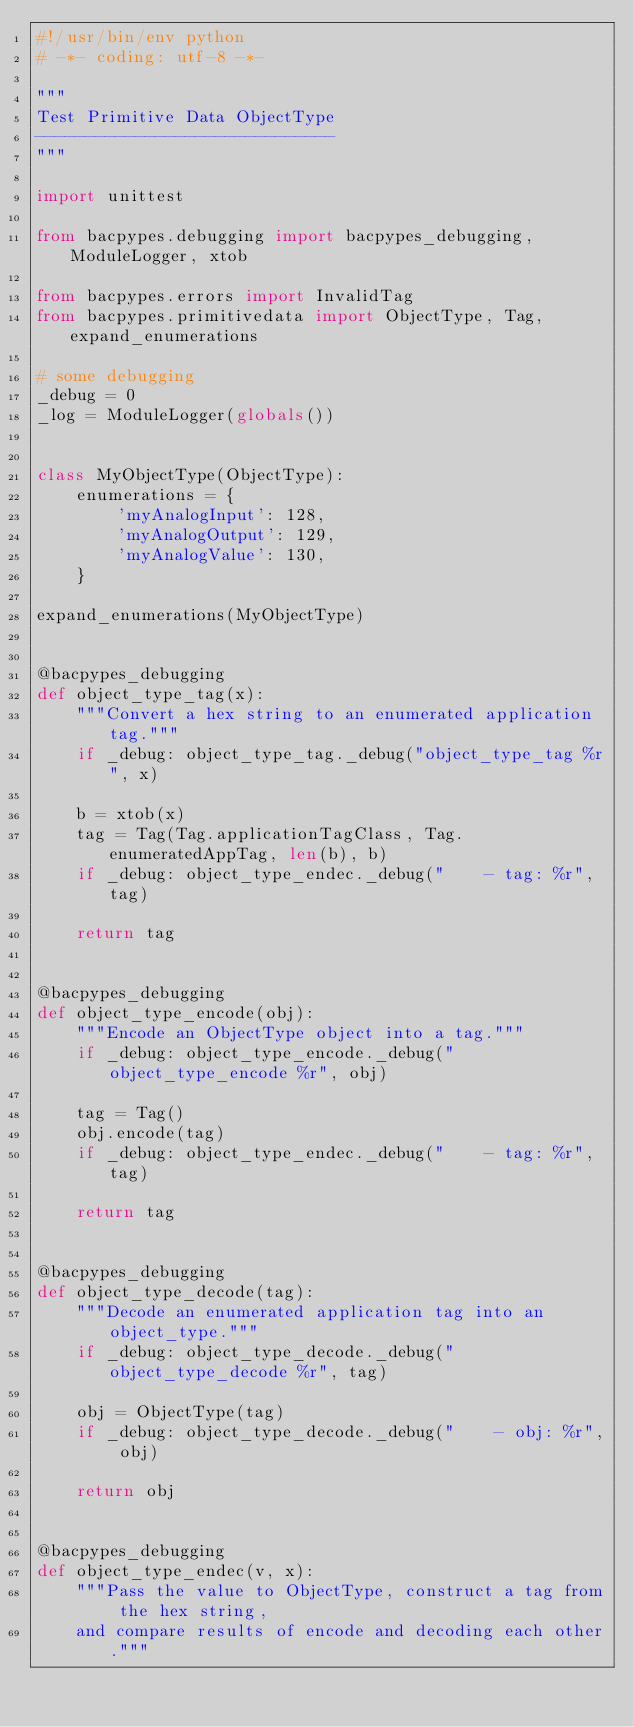<code> <loc_0><loc_0><loc_500><loc_500><_Python_>#!/usr/bin/env python
# -*- coding: utf-8 -*-

"""
Test Primitive Data ObjectType
------------------------------
"""

import unittest

from bacpypes.debugging import bacpypes_debugging, ModuleLogger, xtob

from bacpypes.errors import InvalidTag
from bacpypes.primitivedata import ObjectType, Tag, expand_enumerations

# some debugging
_debug = 0
_log = ModuleLogger(globals())


class MyObjectType(ObjectType):
    enumerations = {
        'myAnalogInput': 128,
        'myAnalogOutput': 129,
        'myAnalogValue': 130,
    }

expand_enumerations(MyObjectType)


@bacpypes_debugging
def object_type_tag(x):
    """Convert a hex string to an enumerated application tag."""
    if _debug: object_type_tag._debug("object_type_tag %r", x)

    b = xtob(x)
    tag = Tag(Tag.applicationTagClass, Tag.enumeratedAppTag, len(b), b)
    if _debug: object_type_endec._debug("    - tag: %r", tag)

    return tag


@bacpypes_debugging
def object_type_encode(obj):
    """Encode an ObjectType object into a tag."""
    if _debug: object_type_encode._debug("object_type_encode %r", obj)

    tag = Tag()
    obj.encode(tag)
    if _debug: object_type_endec._debug("    - tag: %r", tag)

    return tag


@bacpypes_debugging
def object_type_decode(tag):
    """Decode an enumerated application tag into an object_type."""
    if _debug: object_type_decode._debug("object_type_decode %r", tag)

    obj = ObjectType(tag)
    if _debug: object_type_decode._debug("    - obj: %r", obj)

    return obj


@bacpypes_debugging
def object_type_endec(v, x):
    """Pass the value to ObjectType, construct a tag from the hex string,
    and compare results of encode and decoding each other."""</code> 